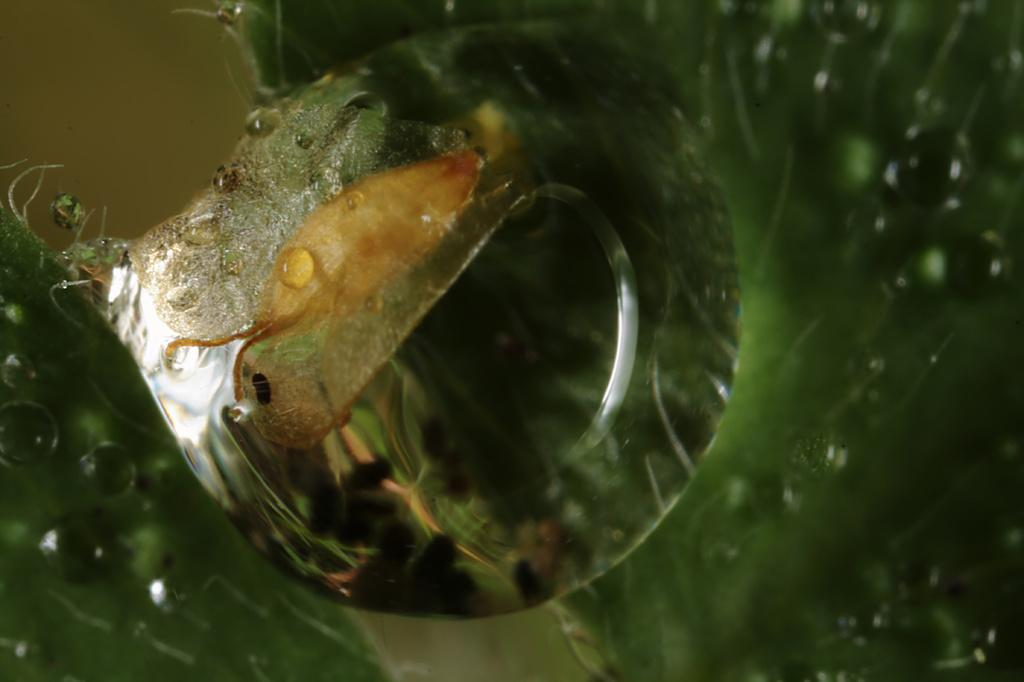What color is the object in the image? The object in the image has a green color. Can you describe the appearance of the object? The object has water droplets on it. Is there a guitar being played by the object in the image? There is no guitar or any indication of playing an instrument in the image. 